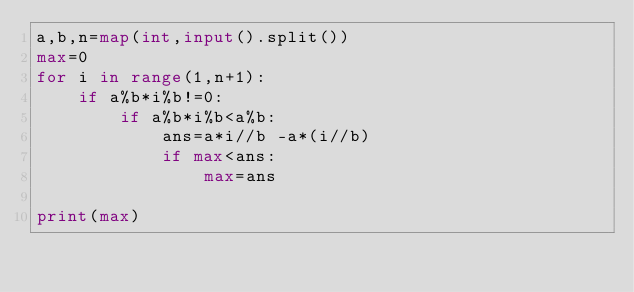<code> <loc_0><loc_0><loc_500><loc_500><_Python_>a,b,n=map(int,input().split())
max=0
for i in range(1,n+1):
    if a%b*i%b!=0:
        if a%b*i%b<a%b:
            ans=a*i//b -a*(i//b)
            if max<ans:
                max=ans

print(max)</code> 